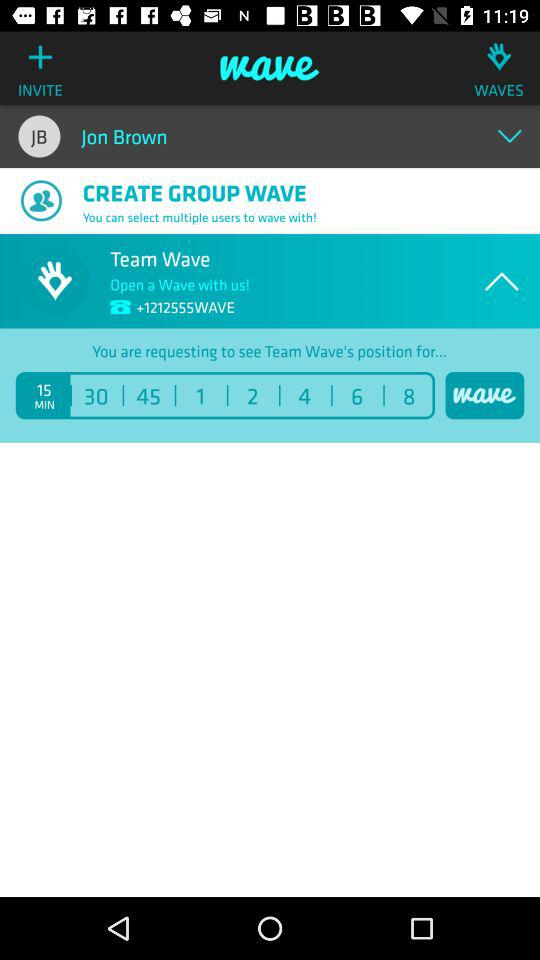Whose name is shown on the top of the screen? The shown name is Jon Brown. 